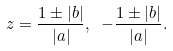<formula> <loc_0><loc_0><loc_500><loc_500>z = \frac { 1 \pm | b | } { | a | } , \ - \frac { 1 \pm | b | } { | a | } .</formula> 